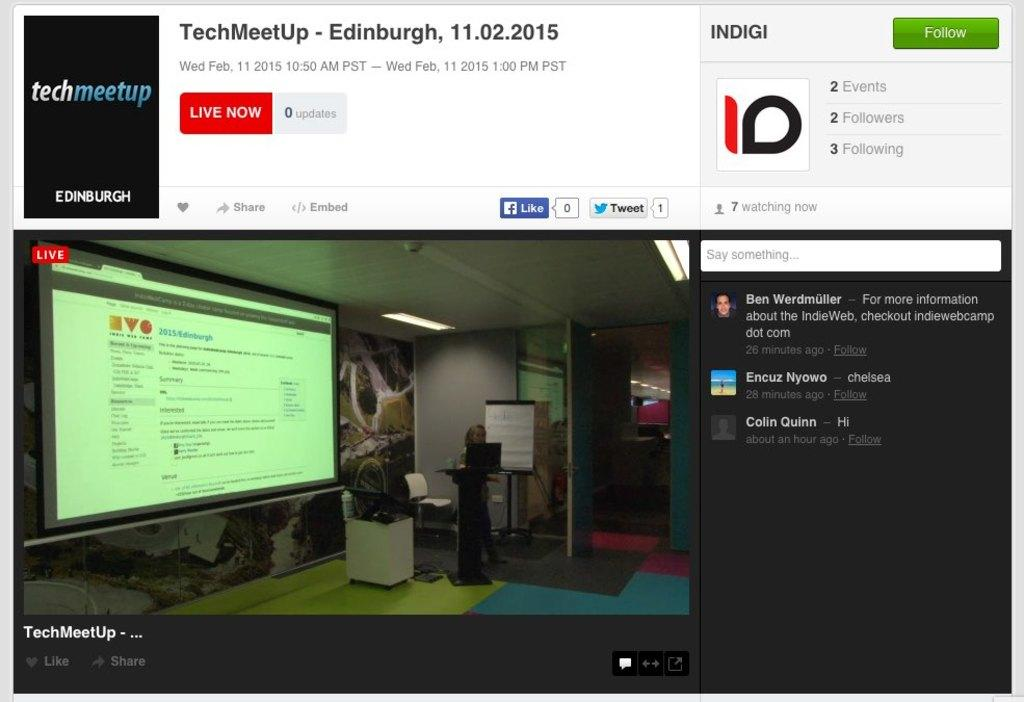<image>
Present a compact description of the photo's key features. A webinar for TechMeet Up is shown as being Live. 